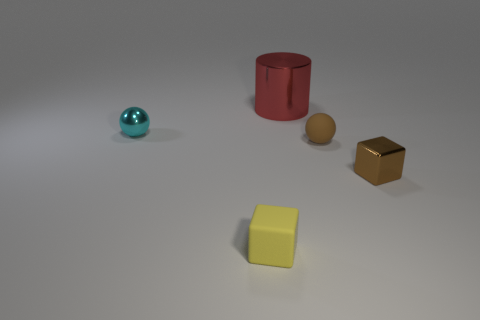How many tiny spheres have the same material as the yellow thing?
Keep it short and to the point. 1. What shape is the small rubber thing that is the same color as the small metallic block?
Offer a terse response. Sphere. There is a object that is behind the tiny cyan metal thing; is its shape the same as the cyan metal thing?
Offer a terse response. No. What color is the small cube that is made of the same material as the cylinder?
Offer a very short reply. Brown. Is there a small rubber block on the right side of the small cube on the left side of the object that is on the right side of the brown matte sphere?
Make the answer very short. No. The yellow thing is what shape?
Provide a short and direct response. Cube. Is the number of cyan balls to the right of the brown cube less than the number of gray spheres?
Make the answer very short. No. Are there any tiny yellow metal objects that have the same shape as the brown rubber thing?
Offer a very short reply. No. The matte object that is the same size as the brown matte ball is what shape?
Your answer should be very brief. Cube. How many objects are either big gray shiny blocks or tiny yellow cubes?
Give a very brief answer. 1. 